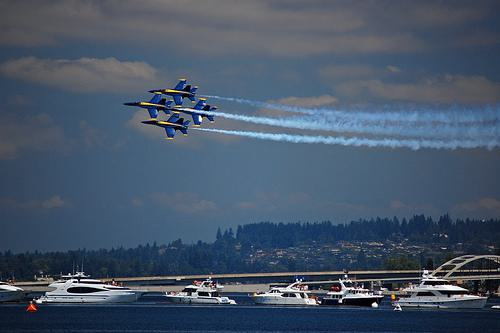What details can you tell me about the jets? The jets in the formation are painted in a distinctive blue and yellow color scheme, which, along with their precision flying, suggests they could belong to a renowned aerobatic display team. The tight-knit formation is typically a challenging maneuver which showcases the pilots' skills and the aircraft's capabilities. How does the weather seem to affect the event? The condition of the sky, which is partly cloudy with ample sunlight, seems to be ideal for an air show. Good weather allows the pilots to perform their stunts more safely and enables the spectators to view the performance unobstructed by harsh elements like rain or dense fog. 